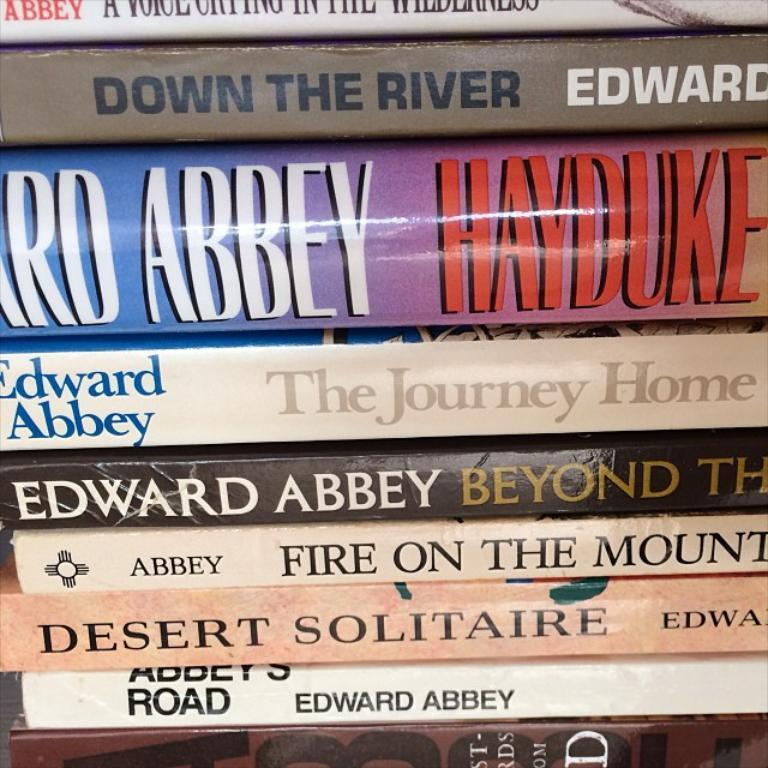<image>
Relay a brief, clear account of the picture shown. the name Edward Abbey is on the book 